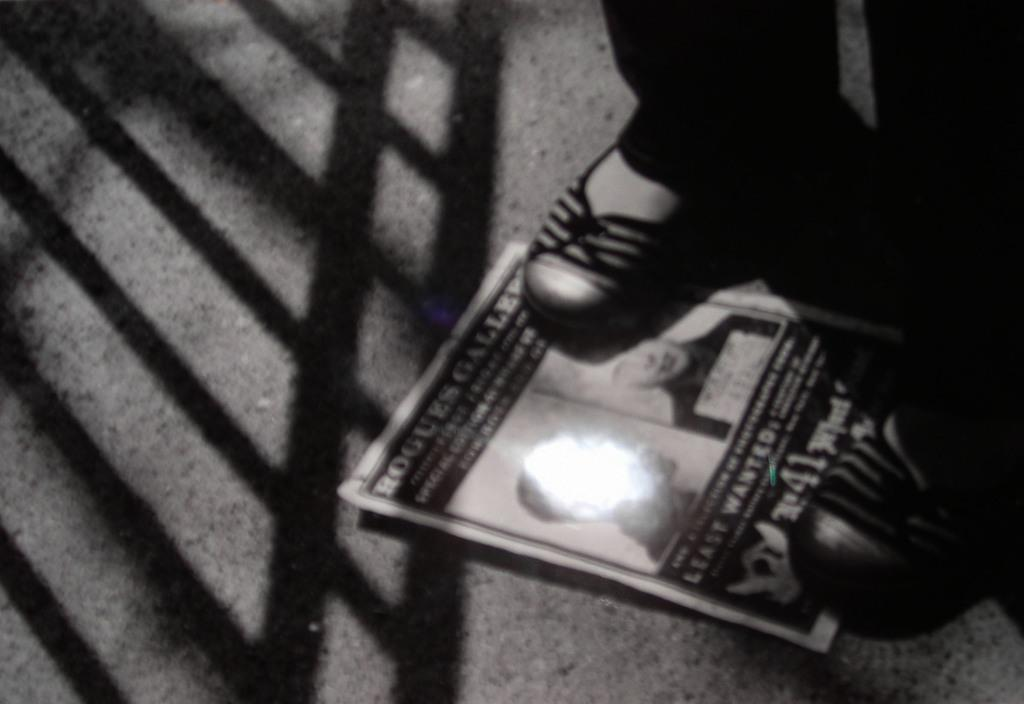What is the main subject in the image? There is a person in the image. What is the person standing on? The person is standing on a paper. Where is the paper located? The paper is placed on the floor. What color are the person's eyes in the image? The provided facts do not mention the person's eye color, so we cannot determine the color of their eyes from the image. 